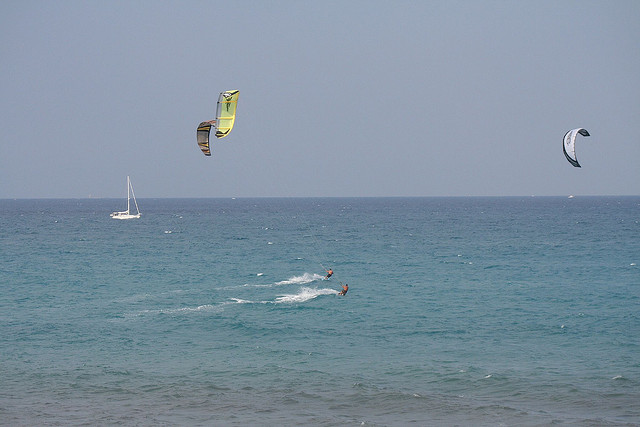What sport are the two people in the water participating in?
A. sailing
B. swimming
C. para waterskiing
D. surfing
Answer with the option's letter from the given choices directly. C 